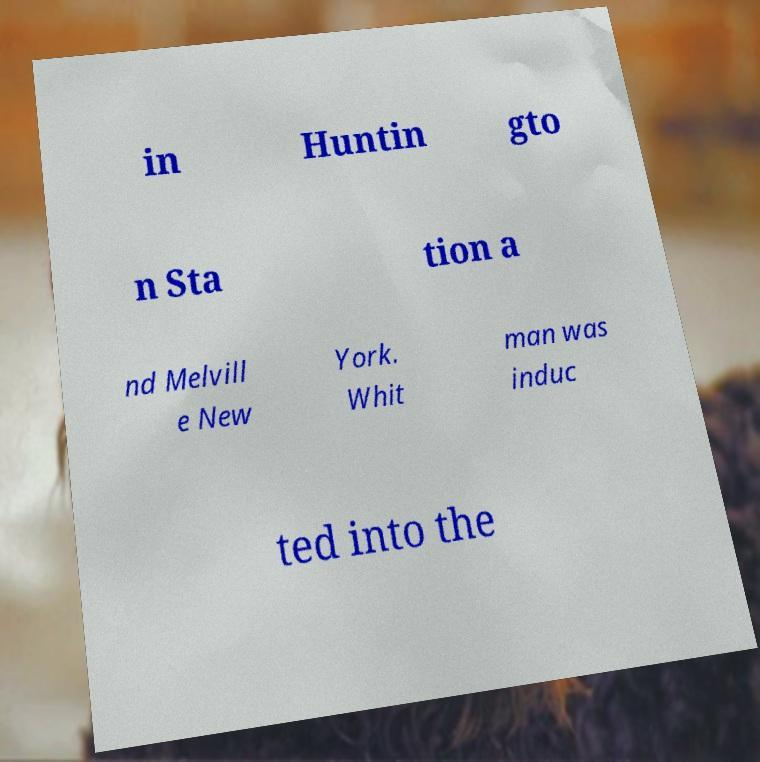What messages or text are displayed in this image? I need them in a readable, typed format. in Huntin gto n Sta tion a nd Melvill e New York. Whit man was induc ted into the 